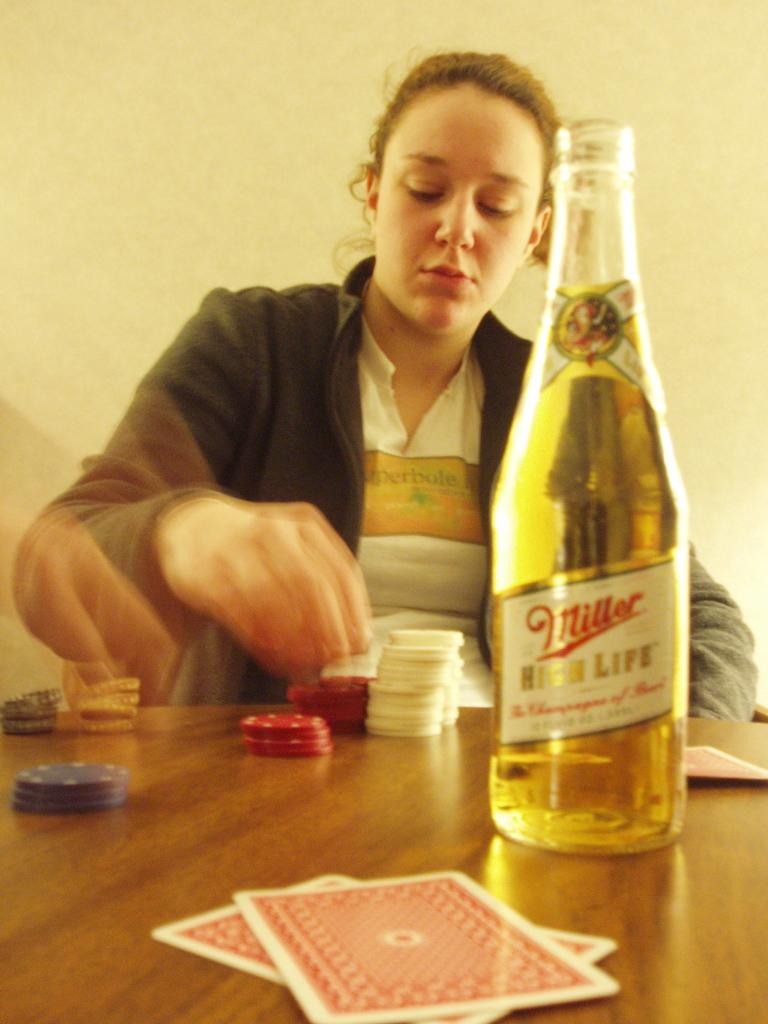What kind of beer in she drinking?
Give a very brief answer. Miller high life. 